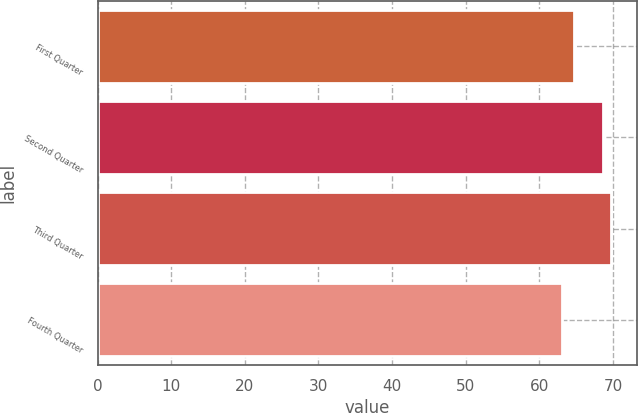<chart> <loc_0><loc_0><loc_500><loc_500><bar_chart><fcel>First Quarter<fcel>Second Quarter<fcel>Third Quarter<fcel>Fourth Quarter<nl><fcel>64.63<fcel>68.66<fcel>69.77<fcel>63.06<nl></chart> 